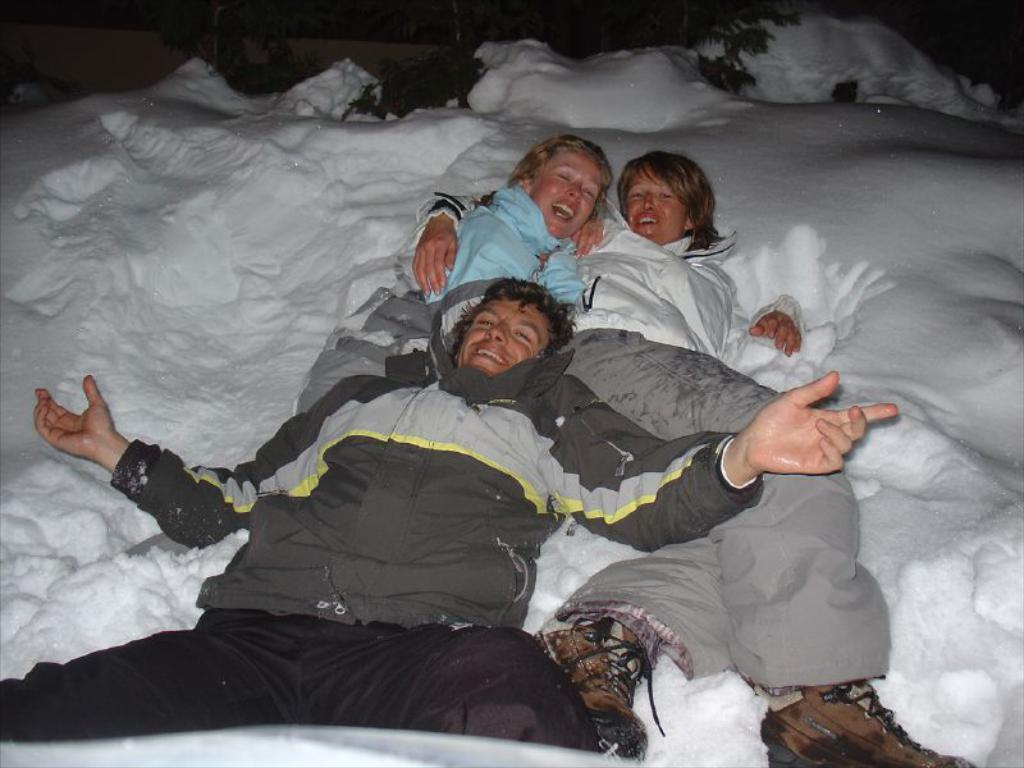How many people are in the image? There are people in the image, but the exact number is not specified. What are the people doing in the image? The people are lying on the snow. What type of apples are being printed on the number of shirts in the image? There are no apples, printing, or shirts present in the image; it features people lying on the snow. 